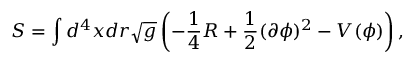<formula> <loc_0><loc_0><loc_500><loc_500>S = \int d ^ { 4 } x d r \sqrt { g } \left ( - \frac { 1 } { 4 } R + \frac { 1 } { 2 } ( \partial \phi ) ^ { 2 } - V ( \phi ) \right ) ,</formula> 